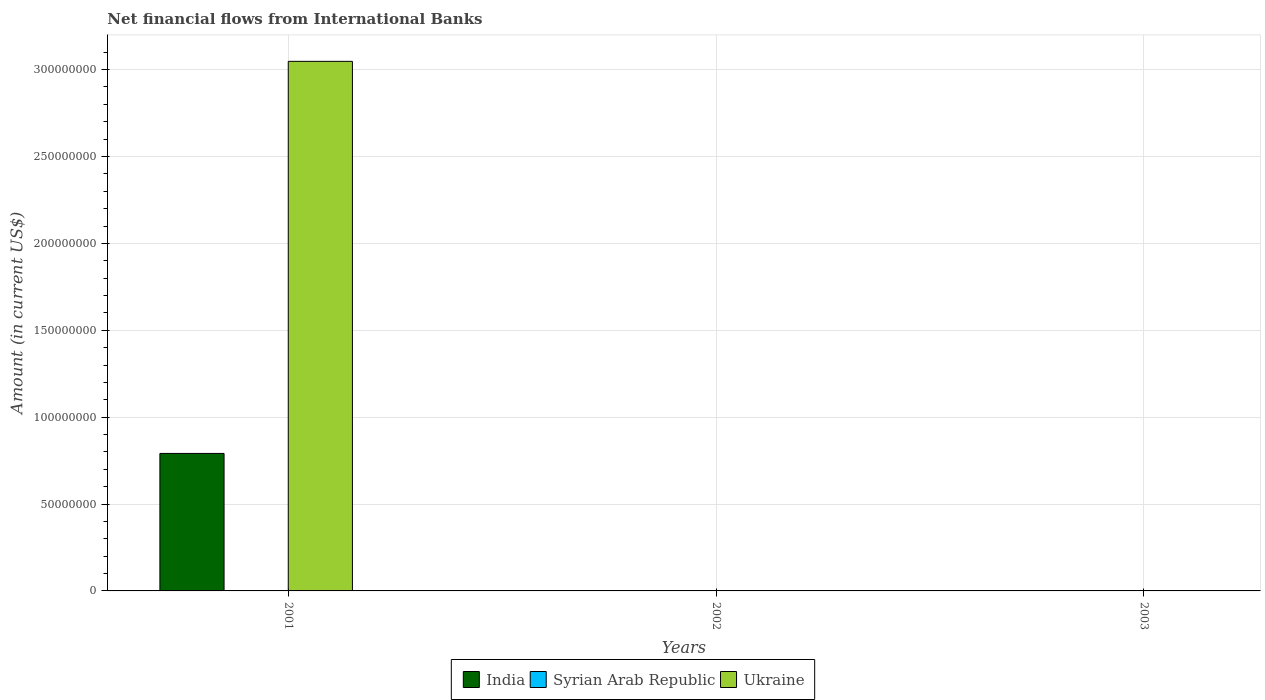What is the label of the 1st group of bars from the left?
Offer a very short reply. 2001. What is the net financial aid flows in Ukraine in 2002?
Your response must be concise. 0. Across all years, what is the maximum net financial aid flows in India?
Give a very brief answer. 7.91e+07. Across all years, what is the minimum net financial aid flows in Ukraine?
Ensure brevity in your answer.  0. What is the difference between the net financial aid flows in Ukraine in 2001 and the net financial aid flows in India in 2002?
Ensure brevity in your answer.  3.05e+08. What is the average net financial aid flows in India per year?
Your response must be concise. 2.64e+07. In the year 2001, what is the difference between the net financial aid flows in Ukraine and net financial aid flows in India?
Give a very brief answer. 2.26e+08. In how many years, is the net financial aid flows in Syrian Arab Republic greater than 230000000 US$?
Provide a succinct answer. 0. What is the difference between the highest and the lowest net financial aid flows in Ukraine?
Keep it short and to the point. 3.05e+08. How many bars are there?
Provide a short and direct response. 2. Are all the bars in the graph horizontal?
Your answer should be compact. No. How many years are there in the graph?
Your answer should be very brief. 3. What is the difference between two consecutive major ticks on the Y-axis?
Your answer should be compact. 5.00e+07. Are the values on the major ticks of Y-axis written in scientific E-notation?
Your answer should be compact. No. Does the graph contain any zero values?
Provide a short and direct response. Yes. Where does the legend appear in the graph?
Provide a short and direct response. Bottom center. How are the legend labels stacked?
Give a very brief answer. Horizontal. What is the title of the graph?
Your answer should be very brief. Net financial flows from International Banks. Does "Cameroon" appear as one of the legend labels in the graph?
Your answer should be compact. No. What is the Amount (in current US$) in India in 2001?
Provide a short and direct response. 7.91e+07. What is the Amount (in current US$) in Ukraine in 2001?
Give a very brief answer. 3.05e+08. What is the Amount (in current US$) in Ukraine in 2002?
Offer a terse response. 0. What is the Amount (in current US$) of India in 2003?
Offer a terse response. 0. What is the Amount (in current US$) of Syrian Arab Republic in 2003?
Keep it short and to the point. 0. Across all years, what is the maximum Amount (in current US$) in India?
Make the answer very short. 7.91e+07. Across all years, what is the maximum Amount (in current US$) in Ukraine?
Give a very brief answer. 3.05e+08. What is the total Amount (in current US$) of India in the graph?
Give a very brief answer. 7.91e+07. What is the total Amount (in current US$) in Syrian Arab Republic in the graph?
Your answer should be very brief. 0. What is the total Amount (in current US$) in Ukraine in the graph?
Offer a very short reply. 3.05e+08. What is the average Amount (in current US$) in India per year?
Your answer should be very brief. 2.64e+07. What is the average Amount (in current US$) in Ukraine per year?
Keep it short and to the point. 1.02e+08. In the year 2001, what is the difference between the Amount (in current US$) of India and Amount (in current US$) of Ukraine?
Your response must be concise. -2.26e+08. What is the difference between the highest and the lowest Amount (in current US$) of India?
Your response must be concise. 7.91e+07. What is the difference between the highest and the lowest Amount (in current US$) in Ukraine?
Your answer should be very brief. 3.05e+08. 